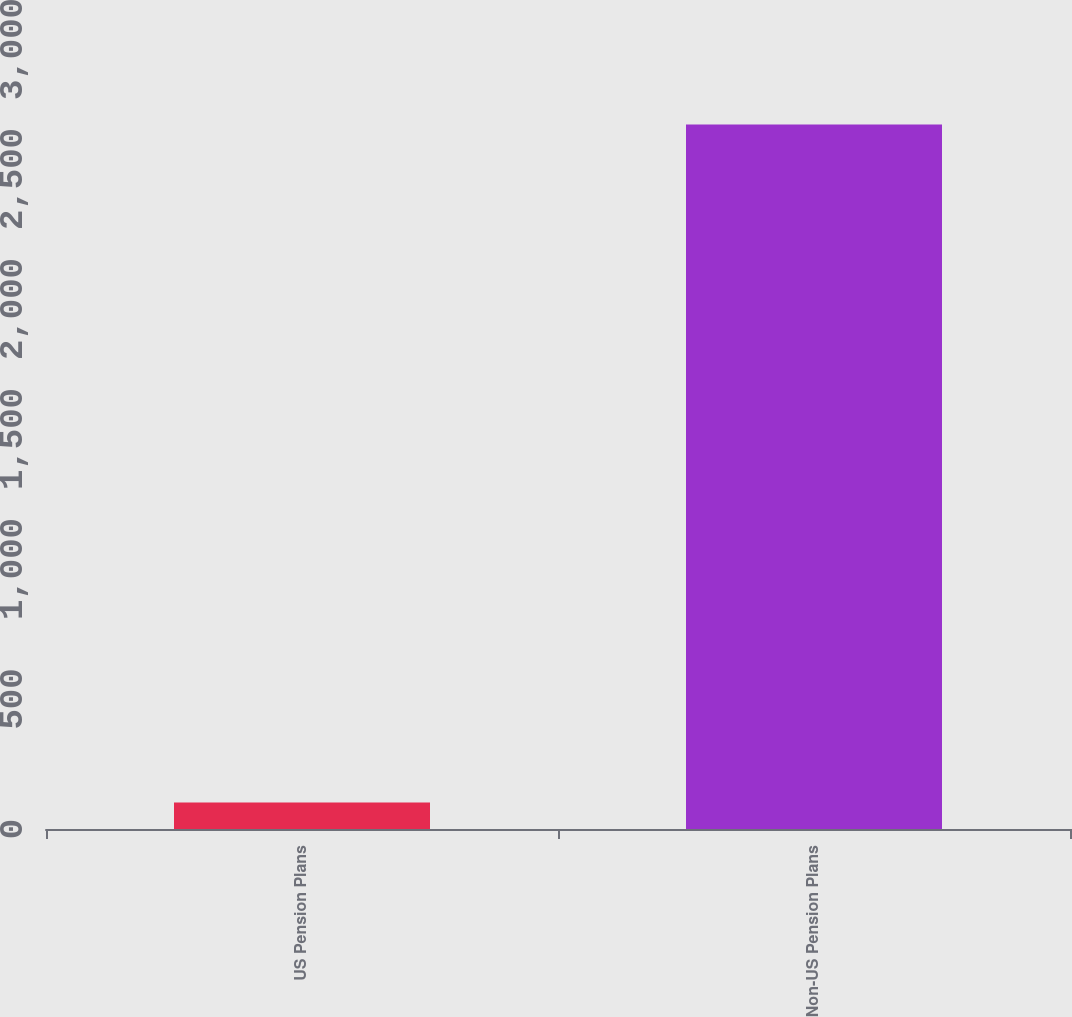Convert chart to OTSL. <chart><loc_0><loc_0><loc_500><loc_500><bar_chart><fcel>US Pension Plans<fcel>Non-US Pension Plans<nl><fcel>102<fcel>2710<nl></chart> 